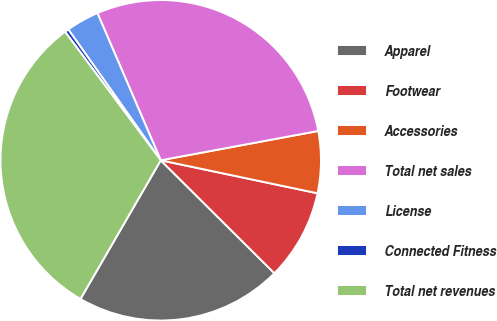Convert chart. <chart><loc_0><loc_0><loc_500><loc_500><pie_chart><fcel>Apparel<fcel>Footwear<fcel>Accessories<fcel>Total net sales<fcel>License<fcel>Connected Fitness<fcel>Total net revenues<nl><fcel>20.9%<fcel>9.15%<fcel>6.23%<fcel>28.54%<fcel>3.32%<fcel>0.4%<fcel>31.46%<nl></chart> 